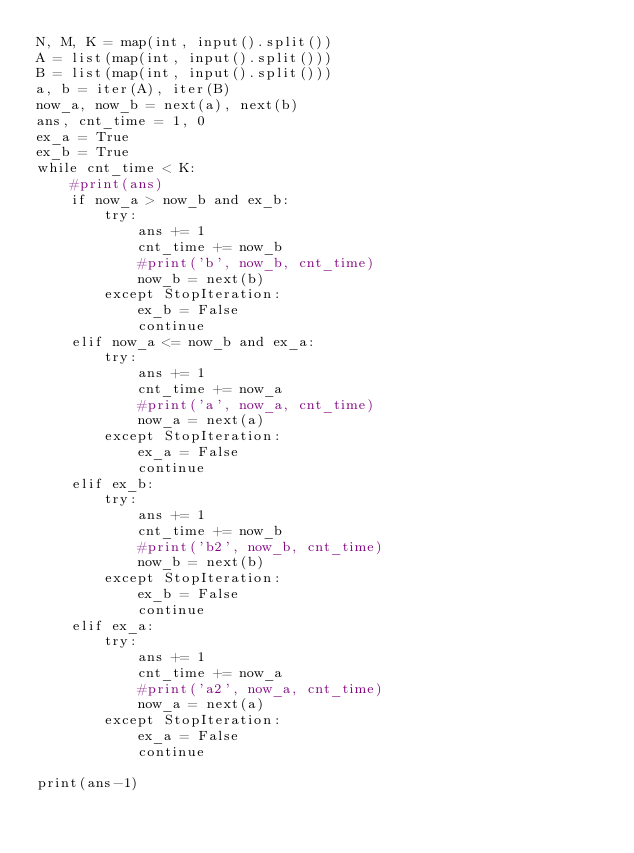Convert code to text. <code><loc_0><loc_0><loc_500><loc_500><_Python_>N, M, K = map(int, input().split())
A = list(map(int, input().split()))
B = list(map(int, input().split()))
a, b = iter(A), iter(B)
now_a, now_b = next(a), next(b)
ans, cnt_time = 1, 0
ex_a = True
ex_b = True
while cnt_time < K:
    #print(ans)
    if now_a > now_b and ex_b:
        try:
            ans += 1
            cnt_time += now_b
            #print('b', now_b, cnt_time)
            now_b = next(b)
        except StopIteration:
            ex_b = False
            continue
    elif now_a <= now_b and ex_a:
        try:
            ans += 1
            cnt_time += now_a
            #print('a', now_a, cnt_time)
            now_a = next(a)
        except StopIteration:
            ex_a = False
            continue
    elif ex_b:
        try:
            ans += 1
            cnt_time += now_b
            #print('b2', now_b, cnt_time)
            now_b = next(b)
        except StopIteration:
            ex_b = False
            continue
    elif ex_a:
        try:
            ans += 1
            cnt_time += now_a
            #print('a2', now_a, cnt_time)
            now_a = next(a)
        except StopIteration:
            ex_a = False
            continue

print(ans-1)</code> 